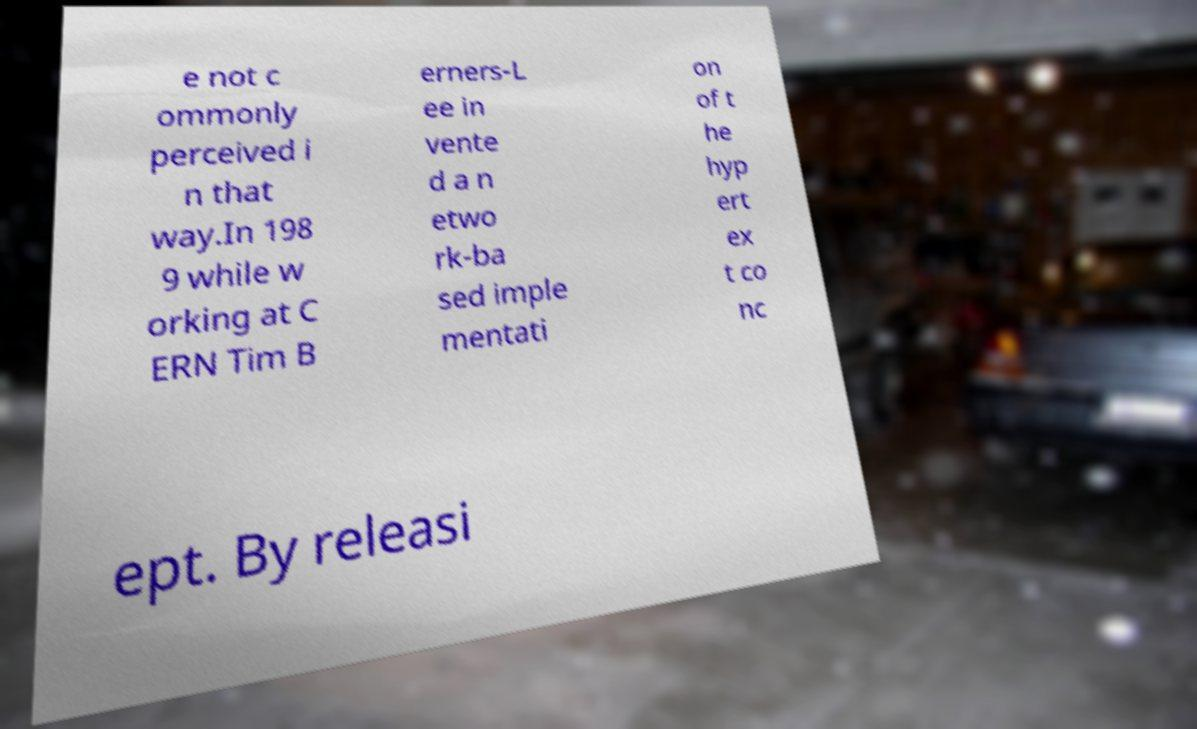Could you extract and type out the text from this image? e not c ommonly perceived i n that way.In 198 9 while w orking at C ERN Tim B erners-L ee in vente d a n etwo rk-ba sed imple mentati on of t he hyp ert ex t co nc ept. By releasi 